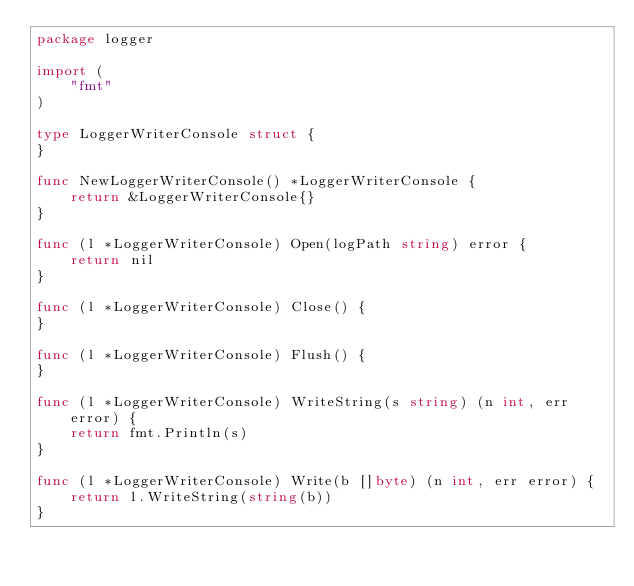Convert code to text. <code><loc_0><loc_0><loc_500><loc_500><_Go_>package logger

import (
	"fmt"
)

type LoggerWriterConsole struct {
}

func NewLoggerWriterConsole() *LoggerWriterConsole {
	return &LoggerWriterConsole{}
}

func (l *LoggerWriterConsole) Open(logPath string) error {
	return nil
}

func (l *LoggerWriterConsole) Close() {
}

func (l *LoggerWriterConsole) Flush() {
}

func (l *LoggerWriterConsole) WriteString(s string) (n int, err error) {
	return fmt.Println(s)
}

func (l *LoggerWriterConsole) Write(b []byte) (n int, err error) {
	return l.WriteString(string(b))
}
</code> 